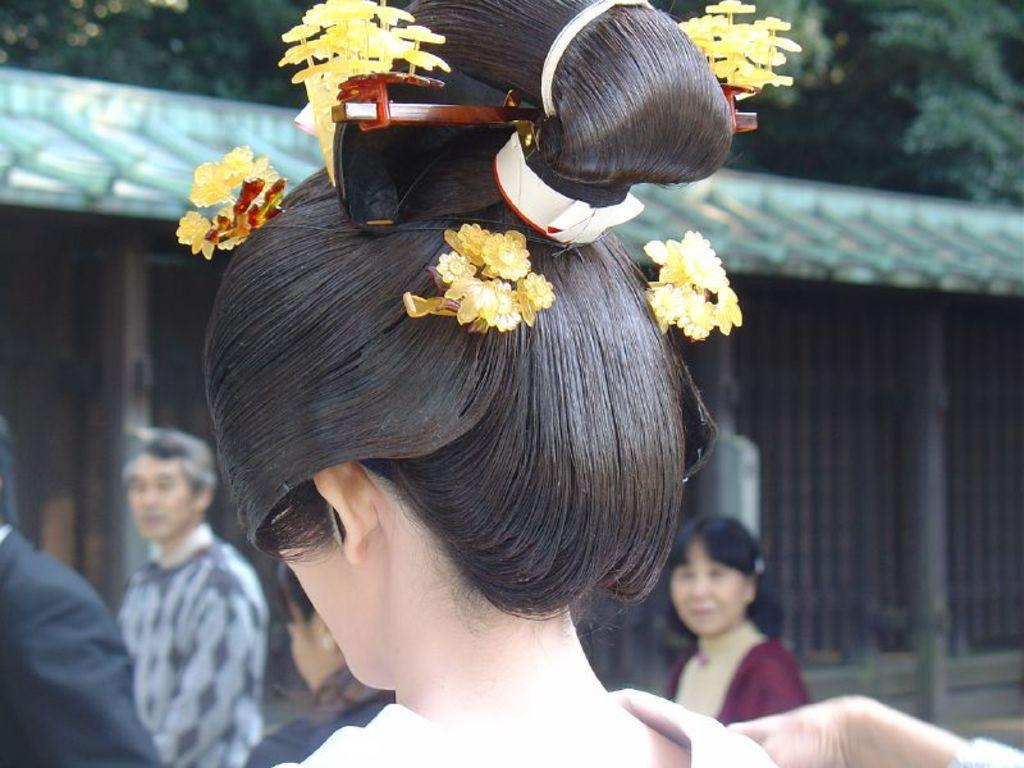Please provide a concise description of this image. In this image, we can see a doll, wearing artificial flowers on the hair and in the background, there are some people, trees and sheds. 